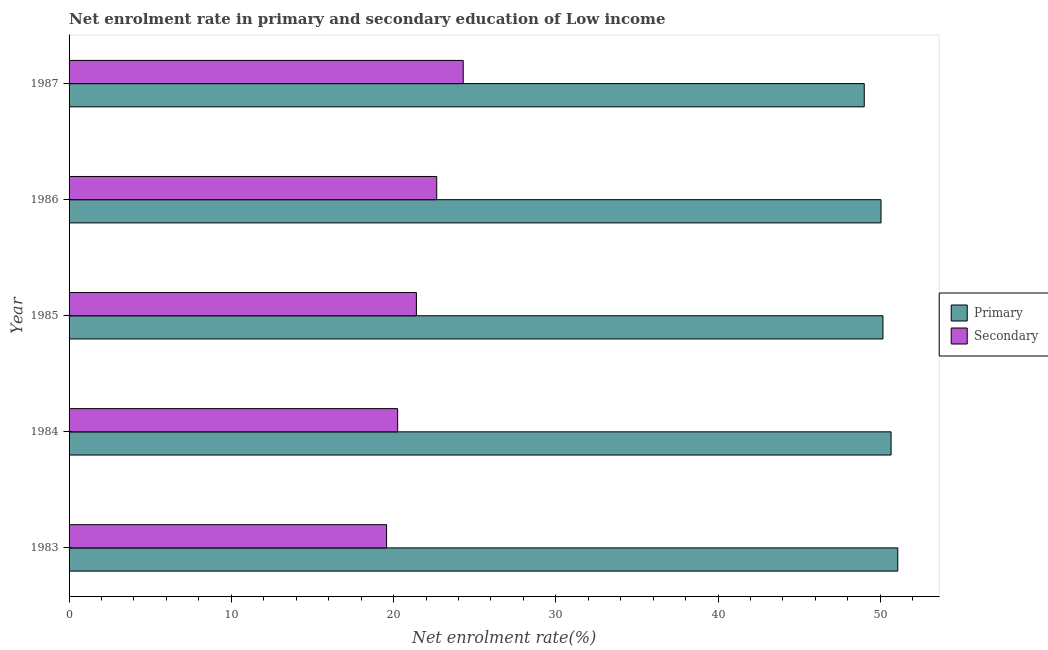Are the number of bars per tick equal to the number of legend labels?
Your response must be concise. Yes. Are the number of bars on each tick of the Y-axis equal?
Provide a succinct answer. Yes. How many bars are there on the 5th tick from the bottom?
Give a very brief answer. 2. What is the enrollment rate in primary education in 1983?
Make the answer very short. 51.08. Across all years, what is the maximum enrollment rate in secondary education?
Your response must be concise. 24.29. Across all years, what is the minimum enrollment rate in primary education?
Your answer should be compact. 49.01. What is the total enrollment rate in primary education in the graph?
Your answer should be very brief. 250.95. What is the difference between the enrollment rate in secondary education in 1984 and that in 1985?
Offer a very short reply. -1.16. What is the difference between the enrollment rate in secondary education in 1983 and the enrollment rate in primary education in 1986?
Ensure brevity in your answer.  -30.47. What is the average enrollment rate in secondary education per year?
Provide a succinct answer. 21.64. In the year 1984, what is the difference between the enrollment rate in primary education and enrollment rate in secondary education?
Provide a succinct answer. 30.41. Is the enrollment rate in secondary education in 1984 less than that in 1985?
Offer a very short reply. Yes. What is the difference between the highest and the second highest enrollment rate in primary education?
Make the answer very short. 0.41. What is the difference between the highest and the lowest enrollment rate in secondary education?
Your response must be concise. 4.72. In how many years, is the enrollment rate in primary education greater than the average enrollment rate in primary education taken over all years?
Ensure brevity in your answer.  2. Is the sum of the enrollment rate in secondary education in 1985 and 1987 greater than the maximum enrollment rate in primary education across all years?
Provide a succinct answer. No. What does the 2nd bar from the top in 1986 represents?
Give a very brief answer. Primary. What does the 2nd bar from the bottom in 1984 represents?
Give a very brief answer. Secondary. How many bars are there?
Offer a very short reply. 10. Are all the bars in the graph horizontal?
Your response must be concise. Yes. How many years are there in the graph?
Give a very brief answer. 5. Are the values on the major ticks of X-axis written in scientific E-notation?
Keep it short and to the point. No. Does the graph contain any zero values?
Give a very brief answer. No. Where does the legend appear in the graph?
Provide a succinct answer. Center right. What is the title of the graph?
Give a very brief answer. Net enrolment rate in primary and secondary education of Low income. What is the label or title of the X-axis?
Provide a succinct answer. Net enrolment rate(%). What is the label or title of the Y-axis?
Make the answer very short. Year. What is the Net enrolment rate(%) of Primary in 1983?
Your response must be concise. 51.08. What is the Net enrolment rate(%) of Secondary in 1983?
Ensure brevity in your answer.  19.57. What is the Net enrolment rate(%) of Primary in 1984?
Keep it short and to the point. 50.66. What is the Net enrolment rate(%) in Secondary in 1984?
Ensure brevity in your answer.  20.25. What is the Net enrolment rate(%) in Primary in 1985?
Your response must be concise. 50.16. What is the Net enrolment rate(%) in Secondary in 1985?
Ensure brevity in your answer.  21.41. What is the Net enrolment rate(%) of Primary in 1986?
Your answer should be compact. 50.04. What is the Net enrolment rate(%) in Secondary in 1986?
Your answer should be very brief. 22.66. What is the Net enrolment rate(%) of Primary in 1987?
Provide a succinct answer. 49.01. What is the Net enrolment rate(%) of Secondary in 1987?
Provide a succinct answer. 24.29. Across all years, what is the maximum Net enrolment rate(%) in Primary?
Provide a succinct answer. 51.08. Across all years, what is the maximum Net enrolment rate(%) of Secondary?
Provide a short and direct response. 24.29. Across all years, what is the minimum Net enrolment rate(%) in Primary?
Give a very brief answer. 49.01. Across all years, what is the minimum Net enrolment rate(%) in Secondary?
Keep it short and to the point. 19.57. What is the total Net enrolment rate(%) in Primary in the graph?
Ensure brevity in your answer.  250.95. What is the total Net enrolment rate(%) of Secondary in the graph?
Offer a very short reply. 108.18. What is the difference between the Net enrolment rate(%) of Primary in 1983 and that in 1984?
Keep it short and to the point. 0.41. What is the difference between the Net enrolment rate(%) of Secondary in 1983 and that in 1984?
Provide a succinct answer. -0.68. What is the difference between the Net enrolment rate(%) in Primary in 1983 and that in 1985?
Keep it short and to the point. 0.91. What is the difference between the Net enrolment rate(%) of Secondary in 1983 and that in 1985?
Your answer should be compact. -1.84. What is the difference between the Net enrolment rate(%) in Primary in 1983 and that in 1986?
Provide a short and direct response. 1.03. What is the difference between the Net enrolment rate(%) in Secondary in 1983 and that in 1986?
Your answer should be compact. -3.09. What is the difference between the Net enrolment rate(%) in Primary in 1983 and that in 1987?
Give a very brief answer. 2.07. What is the difference between the Net enrolment rate(%) in Secondary in 1983 and that in 1987?
Your answer should be very brief. -4.72. What is the difference between the Net enrolment rate(%) in Primary in 1984 and that in 1985?
Offer a terse response. 0.5. What is the difference between the Net enrolment rate(%) in Secondary in 1984 and that in 1985?
Provide a short and direct response. -1.16. What is the difference between the Net enrolment rate(%) of Primary in 1984 and that in 1986?
Provide a short and direct response. 0.62. What is the difference between the Net enrolment rate(%) of Secondary in 1984 and that in 1986?
Your answer should be very brief. -2.41. What is the difference between the Net enrolment rate(%) in Primary in 1984 and that in 1987?
Make the answer very short. 1.65. What is the difference between the Net enrolment rate(%) in Secondary in 1984 and that in 1987?
Offer a terse response. -4.04. What is the difference between the Net enrolment rate(%) of Primary in 1985 and that in 1986?
Ensure brevity in your answer.  0.12. What is the difference between the Net enrolment rate(%) of Secondary in 1985 and that in 1986?
Offer a terse response. -1.25. What is the difference between the Net enrolment rate(%) in Primary in 1985 and that in 1987?
Keep it short and to the point. 1.15. What is the difference between the Net enrolment rate(%) in Secondary in 1985 and that in 1987?
Keep it short and to the point. -2.89. What is the difference between the Net enrolment rate(%) in Primary in 1986 and that in 1987?
Offer a very short reply. 1.03. What is the difference between the Net enrolment rate(%) in Secondary in 1986 and that in 1987?
Offer a very short reply. -1.63. What is the difference between the Net enrolment rate(%) of Primary in 1983 and the Net enrolment rate(%) of Secondary in 1984?
Your response must be concise. 30.82. What is the difference between the Net enrolment rate(%) of Primary in 1983 and the Net enrolment rate(%) of Secondary in 1985?
Keep it short and to the point. 29.67. What is the difference between the Net enrolment rate(%) of Primary in 1983 and the Net enrolment rate(%) of Secondary in 1986?
Offer a terse response. 28.42. What is the difference between the Net enrolment rate(%) in Primary in 1983 and the Net enrolment rate(%) in Secondary in 1987?
Offer a very short reply. 26.78. What is the difference between the Net enrolment rate(%) in Primary in 1984 and the Net enrolment rate(%) in Secondary in 1985?
Keep it short and to the point. 29.26. What is the difference between the Net enrolment rate(%) in Primary in 1984 and the Net enrolment rate(%) in Secondary in 1986?
Make the answer very short. 28. What is the difference between the Net enrolment rate(%) in Primary in 1984 and the Net enrolment rate(%) in Secondary in 1987?
Your answer should be compact. 26.37. What is the difference between the Net enrolment rate(%) of Primary in 1985 and the Net enrolment rate(%) of Secondary in 1986?
Provide a short and direct response. 27.5. What is the difference between the Net enrolment rate(%) in Primary in 1985 and the Net enrolment rate(%) in Secondary in 1987?
Provide a succinct answer. 25.87. What is the difference between the Net enrolment rate(%) of Primary in 1986 and the Net enrolment rate(%) of Secondary in 1987?
Offer a very short reply. 25.75. What is the average Net enrolment rate(%) of Primary per year?
Keep it short and to the point. 50.19. What is the average Net enrolment rate(%) of Secondary per year?
Offer a very short reply. 21.64. In the year 1983, what is the difference between the Net enrolment rate(%) of Primary and Net enrolment rate(%) of Secondary?
Your answer should be very brief. 31.51. In the year 1984, what is the difference between the Net enrolment rate(%) of Primary and Net enrolment rate(%) of Secondary?
Your answer should be very brief. 30.41. In the year 1985, what is the difference between the Net enrolment rate(%) of Primary and Net enrolment rate(%) of Secondary?
Offer a very short reply. 28.76. In the year 1986, what is the difference between the Net enrolment rate(%) of Primary and Net enrolment rate(%) of Secondary?
Ensure brevity in your answer.  27.38. In the year 1987, what is the difference between the Net enrolment rate(%) of Primary and Net enrolment rate(%) of Secondary?
Provide a succinct answer. 24.72. What is the ratio of the Net enrolment rate(%) of Primary in 1983 to that in 1984?
Your response must be concise. 1.01. What is the ratio of the Net enrolment rate(%) in Secondary in 1983 to that in 1984?
Make the answer very short. 0.97. What is the ratio of the Net enrolment rate(%) in Primary in 1983 to that in 1985?
Ensure brevity in your answer.  1.02. What is the ratio of the Net enrolment rate(%) of Secondary in 1983 to that in 1985?
Give a very brief answer. 0.91. What is the ratio of the Net enrolment rate(%) in Primary in 1983 to that in 1986?
Make the answer very short. 1.02. What is the ratio of the Net enrolment rate(%) in Secondary in 1983 to that in 1986?
Ensure brevity in your answer.  0.86. What is the ratio of the Net enrolment rate(%) in Primary in 1983 to that in 1987?
Your response must be concise. 1.04. What is the ratio of the Net enrolment rate(%) of Secondary in 1983 to that in 1987?
Your response must be concise. 0.81. What is the ratio of the Net enrolment rate(%) of Secondary in 1984 to that in 1985?
Keep it short and to the point. 0.95. What is the ratio of the Net enrolment rate(%) of Primary in 1984 to that in 1986?
Ensure brevity in your answer.  1.01. What is the ratio of the Net enrolment rate(%) of Secondary in 1984 to that in 1986?
Ensure brevity in your answer.  0.89. What is the ratio of the Net enrolment rate(%) in Primary in 1984 to that in 1987?
Make the answer very short. 1.03. What is the ratio of the Net enrolment rate(%) of Secondary in 1984 to that in 1987?
Give a very brief answer. 0.83. What is the ratio of the Net enrolment rate(%) in Primary in 1985 to that in 1986?
Keep it short and to the point. 1. What is the ratio of the Net enrolment rate(%) of Secondary in 1985 to that in 1986?
Provide a short and direct response. 0.94. What is the ratio of the Net enrolment rate(%) of Primary in 1985 to that in 1987?
Give a very brief answer. 1.02. What is the ratio of the Net enrolment rate(%) in Secondary in 1985 to that in 1987?
Your response must be concise. 0.88. What is the ratio of the Net enrolment rate(%) in Primary in 1986 to that in 1987?
Provide a succinct answer. 1.02. What is the ratio of the Net enrolment rate(%) of Secondary in 1986 to that in 1987?
Keep it short and to the point. 0.93. What is the difference between the highest and the second highest Net enrolment rate(%) of Primary?
Your answer should be very brief. 0.41. What is the difference between the highest and the second highest Net enrolment rate(%) in Secondary?
Make the answer very short. 1.63. What is the difference between the highest and the lowest Net enrolment rate(%) in Primary?
Provide a succinct answer. 2.07. What is the difference between the highest and the lowest Net enrolment rate(%) of Secondary?
Ensure brevity in your answer.  4.72. 